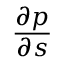<formula> <loc_0><loc_0><loc_500><loc_500>\frac { \partial p } { \partial s }</formula> 